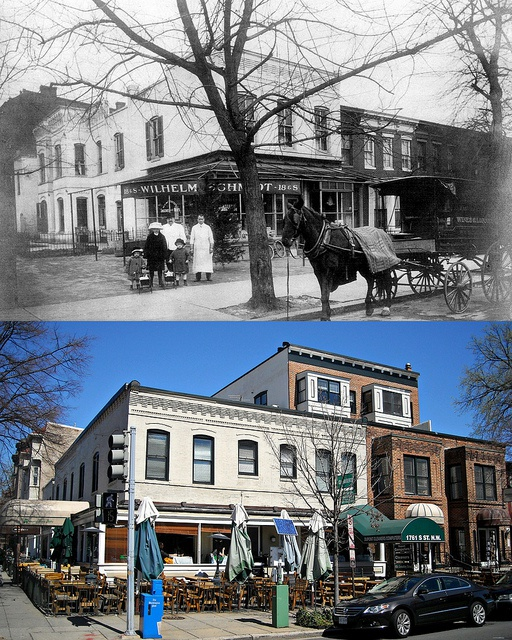Describe the objects in this image and their specific colors. I can see car in white, black, gray, navy, and darkgray tones, horse in white, black, gray, darkgray, and lightgray tones, umbrella in white, black, gray, and blue tones, umbrella in white, black, lightgray, darkgray, and gray tones, and umbrella in white, lightgray, black, darkgray, and gray tones in this image. 